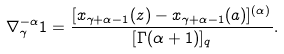<formula> <loc_0><loc_0><loc_500><loc_500>\nabla _ { \gamma } ^ { - \alpha } 1 = \frac { [ x _ { \gamma + \alpha - 1 } ( z ) - x _ { \gamma + \alpha - 1 } ( a ) ] ^ { ( \alpha ) } } { [ \Gamma ( \alpha + 1 ) ] _ { q } } .</formula> 